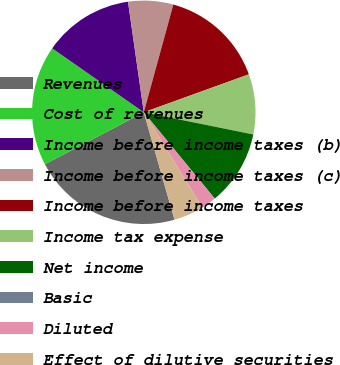Convert chart. <chart><loc_0><loc_0><loc_500><loc_500><pie_chart><fcel>Revenues<fcel>Cost of revenues<fcel>Income before income taxes (b)<fcel>Income before income taxes (c)<fcel>Income before income taxes<fcel>Income tax expense<fcel>Net income<fcel>Basic<fcel>Diluted<fcel>Effect of dilutive securities<nl><fcel>21.74%<fcel>17.39%<fcel>13.04%<fcel>6.52%<fcel>15.22%<fcel>8.7%<fcel>10.87%<fcel>0.0%<fcel>2.17%<fcel>4.35%<nl></chart> 